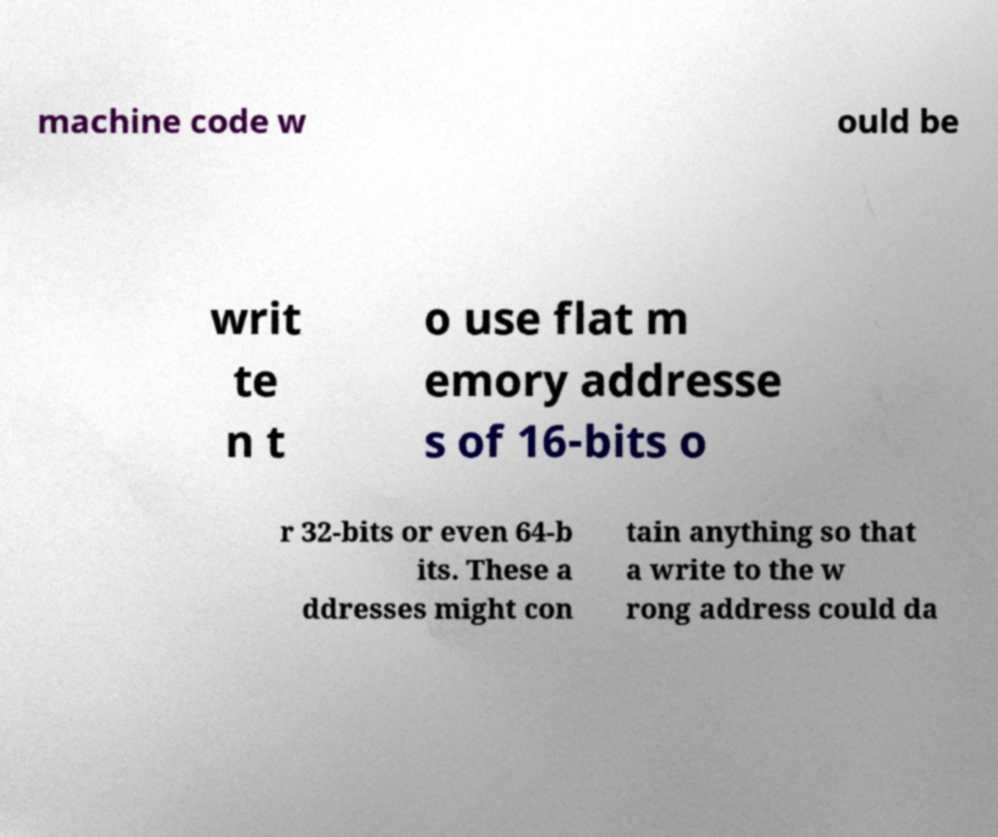Please read and relay the text visible in this image. What does it say? machine code w ould be writ te n t o use flat m emory addresse s of 16-bits o r 32-bits or even 64-b its. These a ddresses might con tain anything so that a write to the w rong address could da 